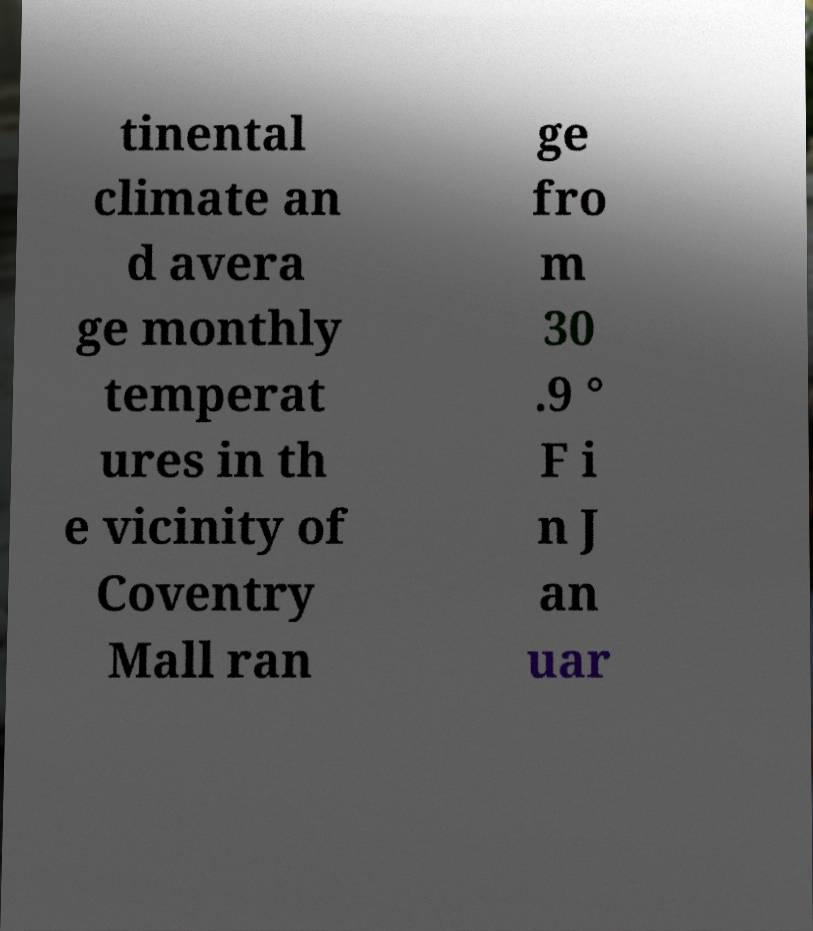Could you assist in decoding the text presented in this image and type it out clearly? tinental climate an d avera ge monthly temperat ures in th e vicinity of Coventry Mall ran ge fro m 30 .9 ° F i n J an uar 